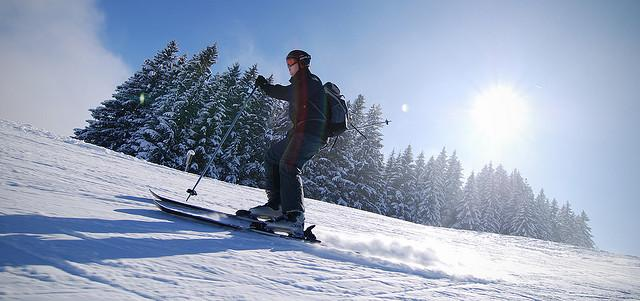What does the giant ball do? Please explain your reasoning. nuclear fusion. The giant ball is the sun. the process of the sun is nuclear fusion. 